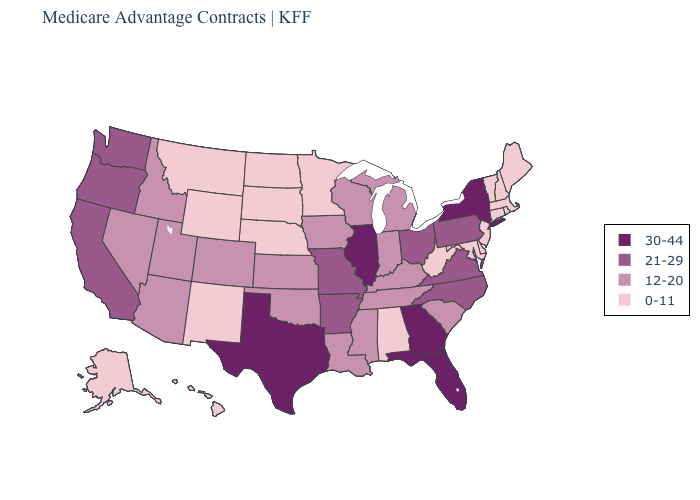Does Kansas have a lower value than Indiana?
Answer briefly. No. Does Kansas have the same value as Iowa?
Give a very brief answer. Yes. Among the states that border Iowa , does Minnesota have the highest value?
Be succinct. No. Does Oregon have a lower value than Texas?
Write a very short answer. Yes. How many symbols are there in the legend?
Keep it brief. 4. Name the states that have a value in the range 0-11?
Answer briefly. Alaska, Alabama, Connecticut, Delaware, Hawaii, Massachusetts, Maryland, Maine, Minnesota, Montana, North Dakota, Nebraska, New Hampshire, New Jersey, New Mexico, Rhode Island, South Dakota, Vermont, West Virginia, Wyoming. Among the states that border New York , which have the lowest value?
Quick response, please. Connecticut, Massachusetts, New Jersey, Vermont. What is the value of Maryland?
Quick response, please. 0-11. Does North Carolina have a higher value than New Hampshire?
Keep it brief. Yes. What is the value of Alabama?
Concise answer only. 0-11. Name the states that have a value in the range 0-11?
Short answer required. Alaska, Alabama, Connecticut, Delaware, Hawaii, Massachusetts, Maryland, Maine, Minnesota, Montana, North Dakota, Nebraska, New Hampshire, New Jersey, New Mexico, Rhode Island, South Dakota, Vermont, West Virginia, Wyoming. Name the states that have a value in the range 30-44?
Be succinct. Florida, Georgia, Illinois, New York, Texas. What is the lowest value in states that border South Dakota?
Keep it brief. 0-11. Name the states that have a value in the range 0-11?
Keep it brief. Alaska, Alabama, Connecticut, Delaware, Hawaii, Massachusetts, Maryland, Maine, Minnesota, Montana, North Dakota, Nebraska, New Hampshire, New Jersey, New Mexico, Rhode Island, South Dakota, Vermont, West Virginia, Wyoming. 